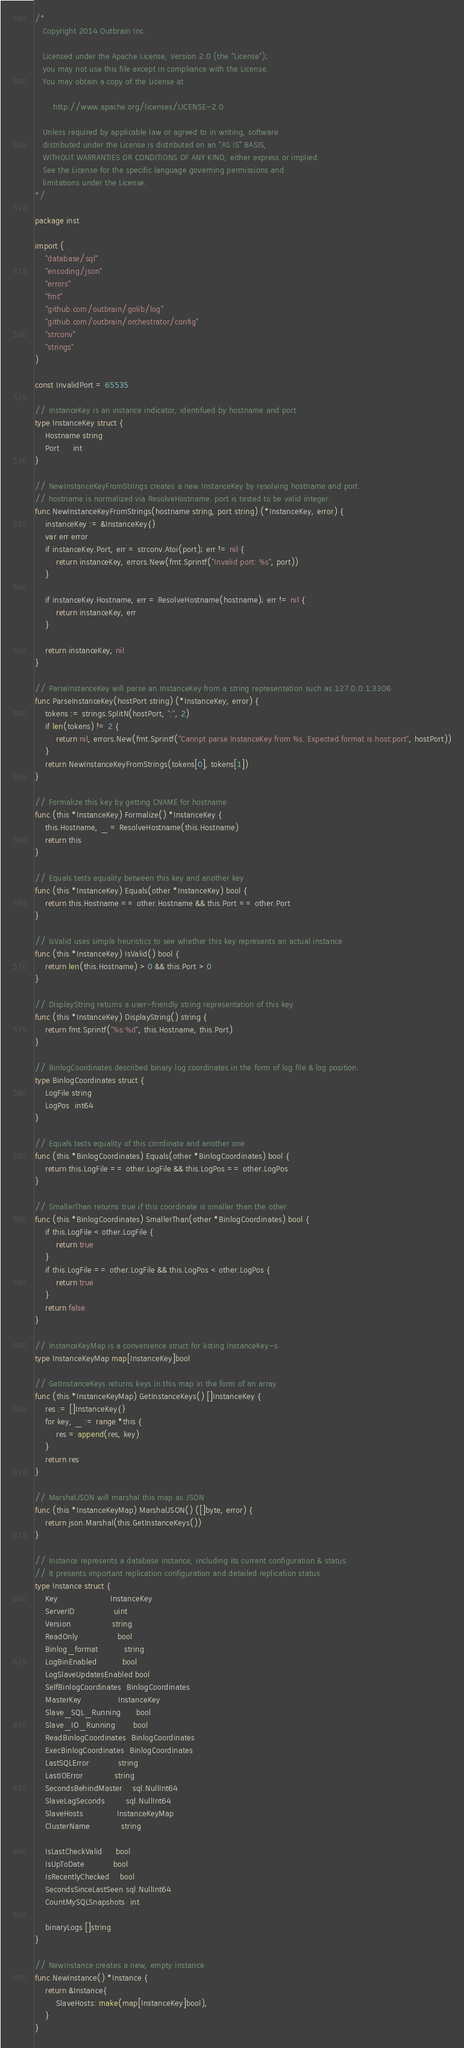Convert code to text. <code><loc_0><loc_0><loc_500><loc_500><_Go_>/*
   Copyright 2014 Outbrain Inc.

   Licensed under the Apache License, Version 2.0 (the "License");
   you may not use this file except in compliance with the License.
   You may obtain a copy of the License at

       http://www.apache.org/licenses/LICENSE-2.0

   Unless required by applicable law or agreed to in writing, software
   distributed under the License is distributed on an "AS IS" BASIS,
   WITHOUT WARRANTIES OR CONDITIONS OF ANY KIND, either express or implied.
   See the License for the specific language governing permissions and
   limitations under the License.
*/

package inst

import (
	"database/sql"
	"encoding/json"
	"errors"
	"fmt"
	"github.com/outbrain/golib/log"
	"github.com/outbrain/orchestrator/config"
	"strconv"
	"strings"
)

const InvalidPort = 65535

// InstanceKey is an instance indicator, identifued by hostname and port
type InstanceKey struct {
	Hostname string
	Port     int
}

// NewInstanceKeyFromStrings creates a new InstanceKey by resolving hostname and port.
// hostname is normalized via ResolveHostname. port is tested to be valid integer.
func NewInstanceKeyFromStrings(hostname string, port string) (*InstanceKey, error) {
	instanceKey := &InstanceKey{}
	var err error
	if instanceKey.Port, err = strconv.Atoi(port); err != nil {
		return instanceKey, errors.New(fmt.Sprintf("Invalid port: %s", port))
	}

	if instanceKey.Hostname, err = ResolveHostname(hostname); err != nil {
		return instanceKey, err
	}

	return instanceKey, nil
}

// ParseInstanceKey will parse an InstanceKey from a string representation such as 127.0.0.1:3306
func ParseInstanceKey(hostPort string) (*InstanceKey, error) {
	tokens := strings.SplitN(hostPort, ":", 2)
	if len(tokens) != 2 {
		return nil, errors.New(fmt.Sprintf("Cannpt parse InstanceKey from %s. Expected format is host:port", hostPort))
	}
	return NewInstanceKeyFromStrings(tokens[0], tokens[1])
}

// Formalize this key by getting CNAME for hostname
func (this *InstanceKey) Formalize() *InstanceKey {
	this.Hostname, _ = ResolveHostname(this.Hostname)
	return this
}

// Equals tests equality between this key and another key
func (this *InstanceKey) Equals(other *InstanceKey) bool {
	return this.Hostname == other.Hostname && this.Port == other.Port
}

// IsValid uses simple heuristics to see whether this key represents an actual instance
func (this *InstanceKey) IsValid() bool {
	return len(this.Hostname) > 0 && this.Port > 0
}

// DisplayString returns a user-friendly string representation of this key
func (this *InstanceKey) DisplayString() string {
	return fmt.Sprintf("%s:%d", this.Hostname, this.Port)
}

// BinlogCoordinates described binary log coordinates in the form of log file & log position.
type BinlogCoordinates struct {
	LogFile string
	LogPos  int64
}

// Equals tests equality of this corrdinate and another one.
func (this *BinlogCoordinates) Equals(other *BinlogCoordinates) bool {
	return this.LogFile == other.LogFile && this.LogPos == other.LogPos
}

// SmallerThan returns true if this coordinate is smaller than the other.
func (this *BinlogCoordinates) SmallerThan(other *BinlogCoordinates) bool {
	if this.LogFile < other.LogFile {
		return true
	}
	if this.LogFile == other.LogFile && this.LogPos < other.LogPos {
		return true
	}
	return false
}

// InstanceKeyMap is a convenience struct for listing InstanceKey-s
type InstanceKeyMap map[InstanceKey]bool

// GetInstanceKeys returns keys in this map in the form of an array
func (this *InstanceKeyMap) GetInstanceKeys() []InstanceKey {
	res := []InstanceKey{}
	for key, _ := range *this {
		res = append(res, key)
	}
	return res
}

// MarshalJSON will marshal this map as JSON
func (this *InstanceKeyMap) MarshalJSON() ([]byte, error) {
	return json.Marshal(this.GetInstanceKeys())
}

// Instance represents a database instance, including its current configuration & status.
// It presents important replication configuration and detailed replication status.
type Instance struct {
	Key                    InstanceKey
	ServerID               uint
	Version                string
	ReadOnly               bool
	Binlog_format          string
	LogBinEnabled          bool
	LogSlaveUpdatesEnabled bool
	SelfBinlogCoordinates  BinlogCoordinates
	MasterKey              InstanceKey
	Slave_SQL_Running      bool
	Slave_IO_Running       bool
	ReadBinlogCoordinates  BinlogCoordinates
	ExecBinlogCoordinates  BinlogCoordinates
	LastSQLError           string
	LastIOError            string
	SecondsBehindMaster    sql.NullInt64
	SlaveLagSeconds        sql.NullInt64
	SlaveHosts             InstanceKeyMap
	ClusterName            string

	IsLastCheckValid     bool
	IsUpToDate           bool
	IsRecentlyChecked    bool
	SecondsSinceLastSeen sql.NullInt64
	CountMySQLSnapshots  int

	binaryLogs []string
}

// NewInstance creates a new, empty instance
func NewInstance() *Instance {
	return &Instance{
		SlaveHosts: make(map[InstanceKey]bool),
	}
}
</code> 